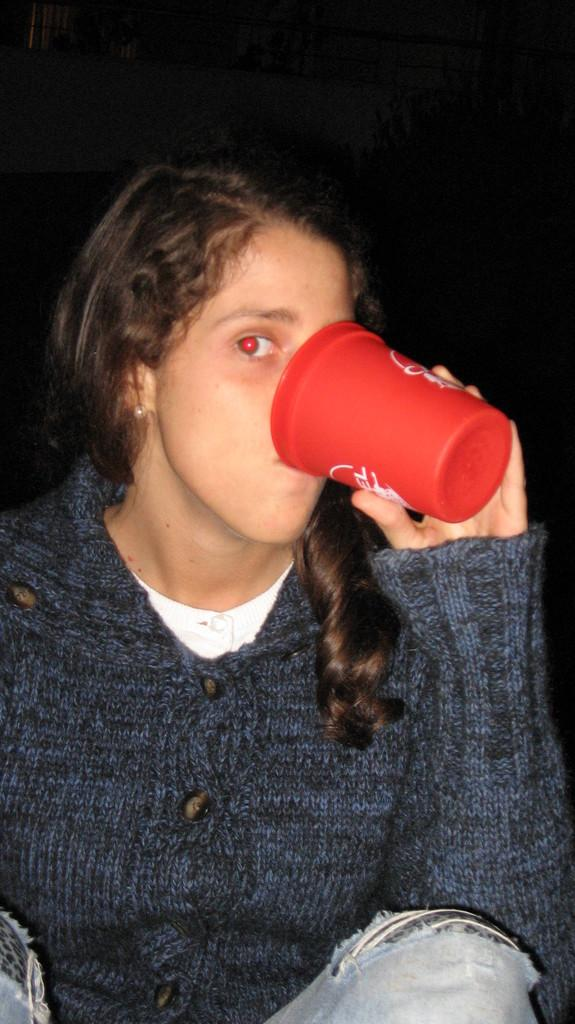Who is the main subject in the image? There is a girl in the image. What is the girl doing in the image? The girl is sitting. What object is the girl holding in the image? The girl is holding a glass. What type of error can be seen in the image? There is no error present in the image; it is a clear image of a girl sitting and holding a glass. 